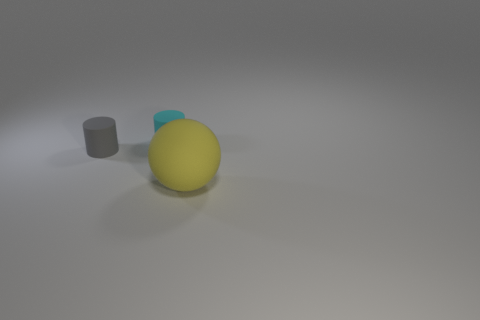Add 1 small cyan matte cylinders. How many objects exist? 4 Subtract 2 cylinders. How many cylinders are left? 0 Subtract all red cylinders. Subtract all brown cubes. How many cylinders are left? 2 Subtract all green cubes. How many gray cylinders are left? 1 Subtract all big red matte cubes. Subtract all small gray matte things. How many objects are left? 2 Add 3 yellow rubber objects. How many yellow rubber objects are left? 4 Add 2 big rubber objects. How many big rubber objects exist? 3 Subtract 0 red balls. How many objects are left? 3 Subtract all cylinders. How many objects are left? 1 